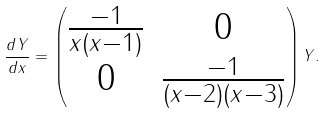<formula> <loc_0><loc_0><loc_500><loc_500>\frac { d Y } { d x } = \begin{pmatrix} \frac { - 1 } { x ( x - 1 ) } & 0 \\ 0 & \frac { - 1 } { ( x - 2 ) ( x - 3 ) } \end{pmatrix} Y .</formula> 